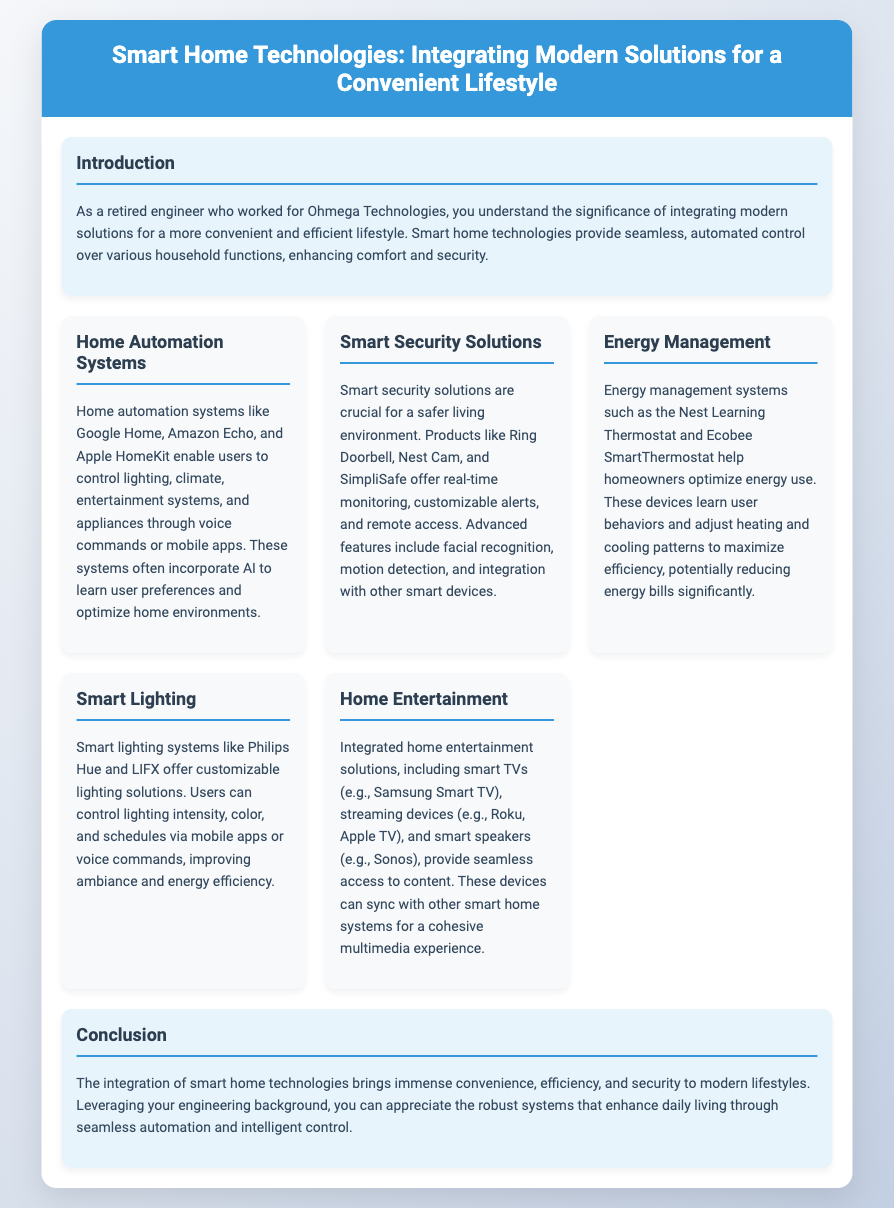What is the title of the presentation? The title is prominently displayed at the top of the slide and clearly states the topic being covered.
Answer: Smart Home Technologies: Integrating Modern Solutions for a Convenient Lifestyle What are some examples of home automation systems mentioned? The document lists specific home automation systems as part of the content.
Answer: Google Home, Amazon Echo, Apple HomeKit What is one function of smart security solutions? The text indicates specific capabilities of smart security solutions available in the document.
Answer: Real-time monitoring Which energy management system is mentioned? The document mentions specific products related to energy management within the slide content.
Answer: Nest Learning Thermostat What is highlighted as a benefit of smart lighting systems? The document discusses the benefits associated with smart lighting solutions.
Answer: Customizable lighting solutions What is the focus of the conclusion section? The conclusion reiterates the overarching themes and advantages of smart home technology mentioned throughout the document.
Answer: Convenience, efficiency, and security What type of devices are listed under home entertainment? This part of the slide lists specific examples of devices used for home entertainment, which are relevant to the topic.
Answer: Smart TVs, streaming devices, smart speakers 